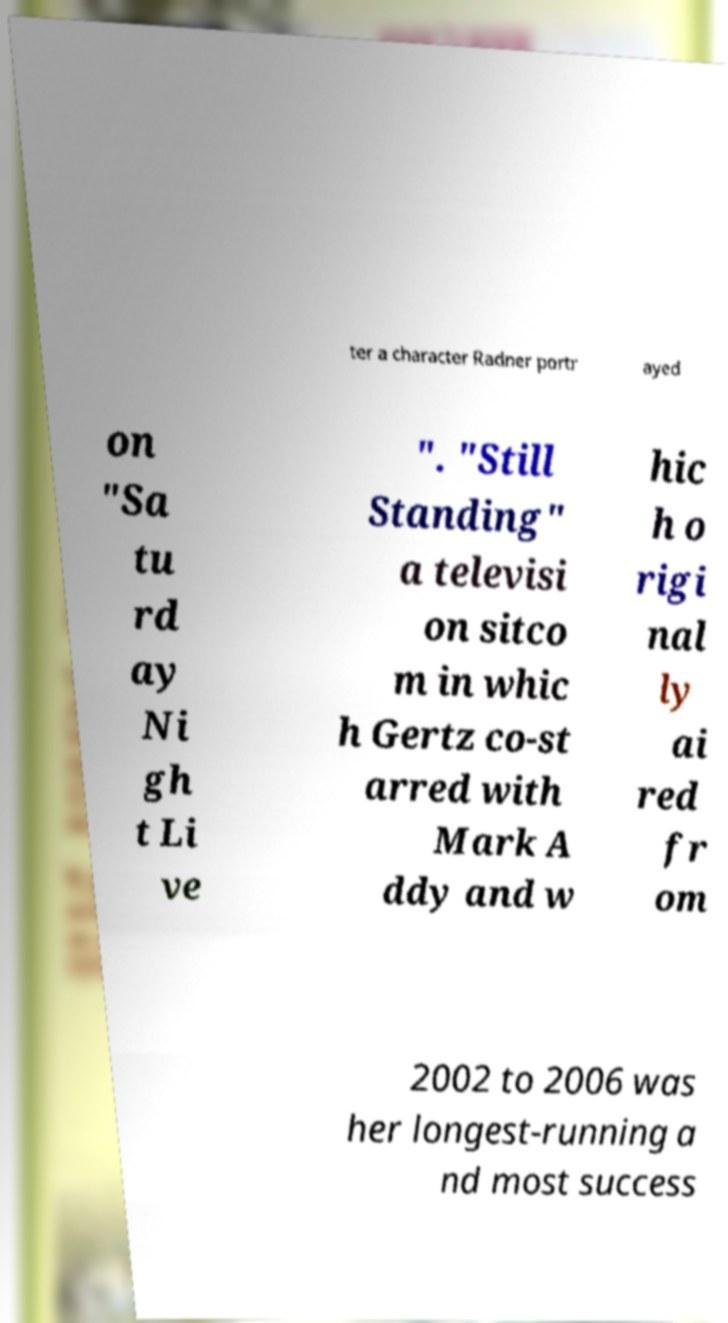For documentation purposes, I need the text within this image transcribed. Could you provide that? ter a character Radner portr ayed on "Sa tu rd ay Ni gh t Li ve ". "Still Standing" a televisi on sitco m in whic h Gertz co-st arred with Mark A ddy and w hic h o rigi nal ly ai red fr om 2002 to 2006 was her longest-running a nd most success 